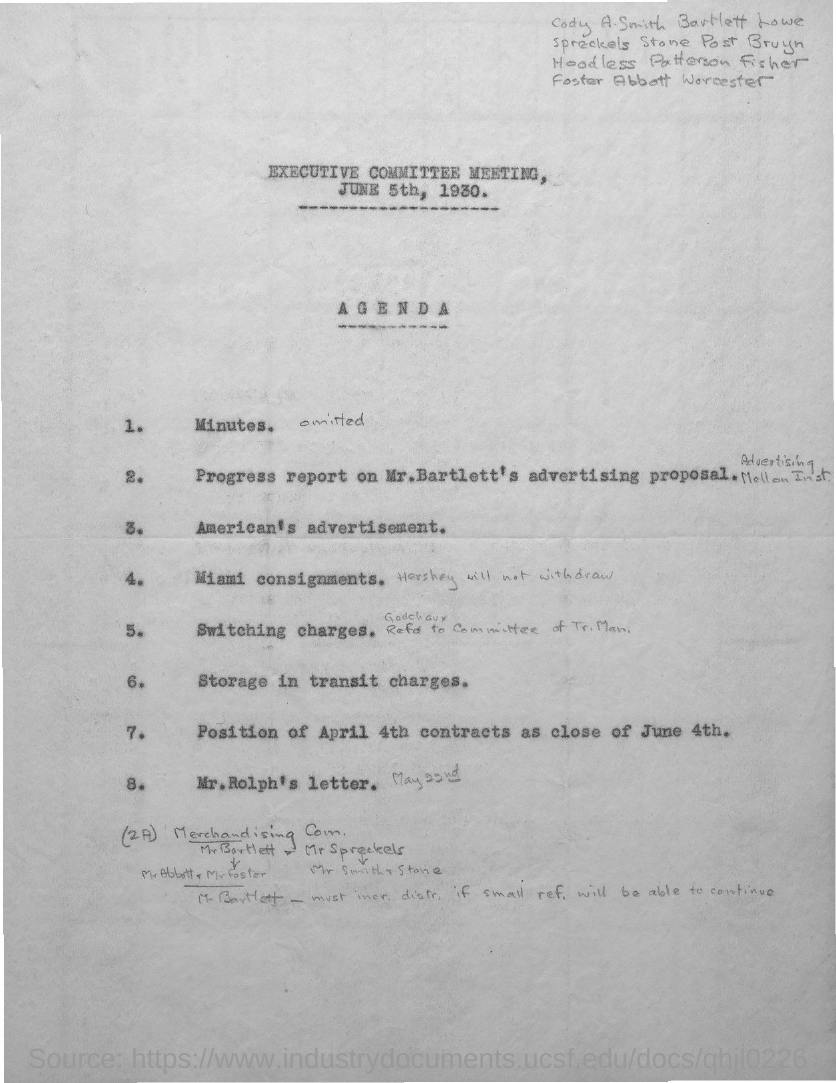What is the Agenda number 6?
Provide a short and direct response. Storage in transit charges. What is the Agenda number 3?
Your answer should be compact. American's advertisement. 